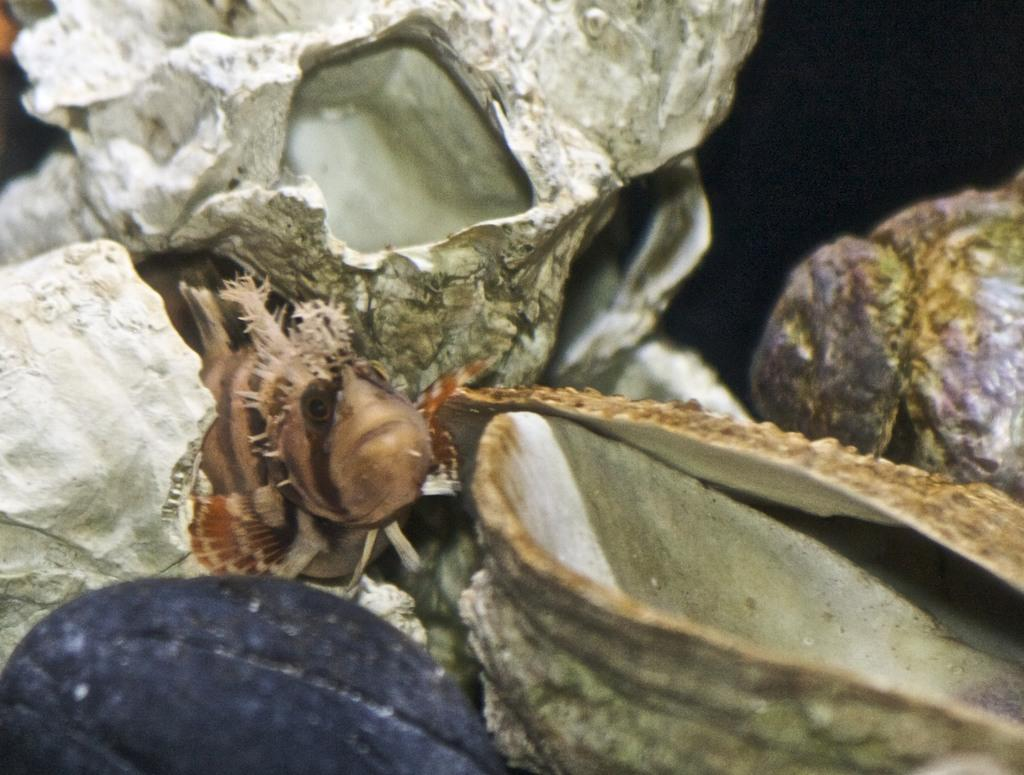What is the main subject of the image? There is a fish in the center of the image. Are there any other objects or subjects in the image besides the fish? The facts provided only mention that there are objects in the image, but they do not specify what those objects are. How many times does the arm kick the land in the image? There is no arm or land present in the image; it only features a fish. 